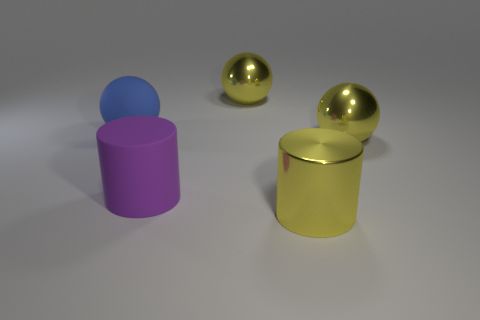Are there any large rubber cylinders?
Your response must be concise. Yes. What size is the cylinder left of the yellow ball on the left side of the large yellow sphere that is in front of the matte ball?
Make the answer very short. Large. What number of big balls are the same material as the big yellow cylinder?
Provide a short and direct response. 2. How many metal objects are the same size as the purple cylinder?
Provide a short and direct response. 3. What material is the yellow thing behind the big blue rubber ball to the left of the big yellow metal sphere behind the large blue matte ball?
Ensure brevity in your answer.  Metal. What number of things are either purple rubber cylinders or big cylinders?
Ensure brevity in your answer.  2. Is there anything else that is made of the same material as the big blue ball?
Provide a succinct answer. Yes. What shape is the blue rubber thing?
Give a very brief answer. Sphere. The yellow shiny object that is to the left of the thing that is in front of the purple rubber thing is what shape?
Provide a succinct answer. Sphere. Do the ball on the left side of the purple rubber cylinder and the yellow cylinder have the same material?
Your response must be concise. No. 